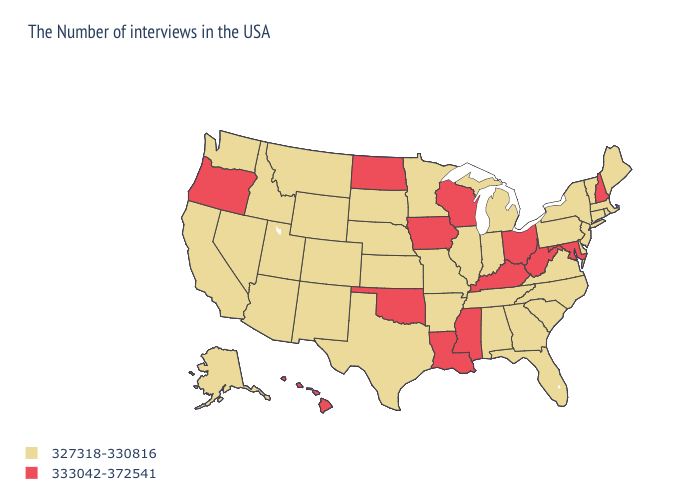What is the lowest value in the USA?
Answer briefly. 327318-330816. Among the states that border North Dakota , which have the lowest value?
Quick response, please. Minnesota, South Dakota, Montana. Which states have the highest value in the USA?
Write a very short answer. New Hampshire, Maryland, West Virginia, Ohio, Kentucky, Wisconsin, Mississippi, Louisiana, Iowa, Oklahoma, North Dakota, Oregon, Hawaii. Name the states that have a value in the range 327318-330816?
Answer briefly. Maine, Massachusetts, Rhode Island, Vermont, Connecticut, New York, New Jersey, Delaware, Pennsylvania, Virginia, North Carolina, South Carolina, Florida, Georgia, Michigan, Indiana, Alabama, Tennessee, Illinois, Missouri, Arkansas, Minnesota, Kansas, Nebraska, Texas, South Dakota, Wyoming, Colorado, New Mexico, Utah, Montana, Arizona, Idaho, Nevada, California, Washington, Alaska. Name the states that have a value in the range 333042-372541?
Quick response, please. New Hampshire, Maryland, West Virginia, Ohio, Kentucky, Wisconsin, Mississippi, Louisiana, Iowa, Oklahoma, North Dakota, Oregon, Hawaii. Name the states that have a value in the range 327318-330816?
Keep it brief. Maine, Massachusetts, Rhode Island, Vermont, Connecticut, New York, New Jersey, Delaware, Pennsylvania, Virginia, North Carolina, South Carolina, Florida, Georgia, Michigan, Indiana, Alabama, Tennessee, Illinois, Missouri, Arkansas, Minnesota, Kansas, Nebraska, Texas, South Dakota, Wyoming, Colorado, New Mexico, Utah, Montana, Arizona, Idaho, Nevada, California, Washington, Alaska. Name the states that have a value in the range 333042-372541?
Give a very brief answer. New Hampshire, Maryland, West Virginia, Ohio, Kentucky, Wisconsin, Mississippi, Louisiana, Iowa, Oklahoma, North Dakota, Oregon, Hawaii. What is the value of Texas?
Keep it brief. 327318-330816. Name the states that have a value in the range 327318-330816?
Quick response, please. Maine, Massachusetts, Rhode Island, Vermont, Connecticut, New York, New Jersey, Delaware, Pennsylvania, Virginia, North Carolina, South Carolina, Florida, Georgia, Michigan, Indiana, Alabama, Tennessee, Illinois, Missouri, Arkansas, Minnesota, Kansas, Nebraska, Texas, South Dakota, Wyoming, Colorado, New Mexico, Utah, Montana, Arizona, Idaho, Nevada, California, Washington, Alaska. Which states have the lowest value in the USA?
Short answer required. Maine, Massachusetts, Rhode Island, Vermont, Connecticut, New York, New Jersey, Delaware, Pennsylvania, Virginia, North Carolina, South Carolina, Florida, Georgia, Michigan, Indiana, Alabama, Tennessee, Illinois, Missouri, Arkansas, Minnesota, Kansas, Nebraska, Texas, South Dakota, Wyoming, Colorado, New Mexico, Utah, Montana, Arizona, Idaho, Nevada, California, Washington, Alaska. What is the value of Montana?
Answer briefly. 327318-330816. Among the states that border Arizona , which have the highest value?
Short answer required. Colorado, New Mexico, Utah, Nevada, California. What is the lowest value in states that border Wisconsin?
Quick response, please. 327318-330816. What is the value of Illinois?
Give a very brief answer. 327318-330816. Does Washington have the highest value in the USA?
Keep it brief. No. 